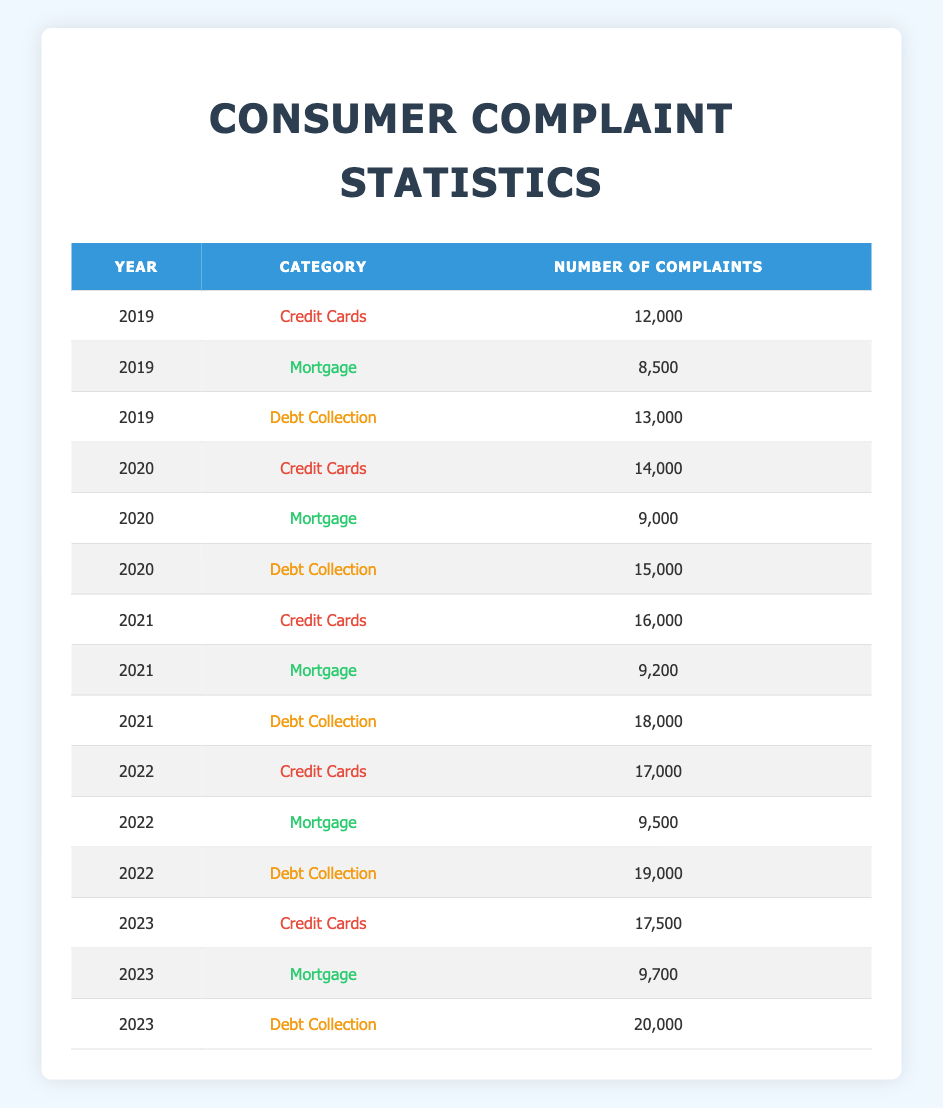What year had the highest number of complaints for mortgages? In the table, we look at the "Mortgage" category across each year. The counts are 8500 (2019), 9000 (2020), 9200 (2021), 9500 (2022), and 9700 (2023). The highest number is 9700 in 2023.
Answer: 2023 What is the total number of complaints for Debt Collection across all years? To find the total, we sum the complaints for Debt Collection: 13000 (2019) + 15000 (2020) + 18000 (2021) + 19000 (2022) + 20000 (2023) = 100000.
Answer: 100000 In 2021, how many more complaints were there for Credit Cards compared to Mortgages? The number of complaints for Credit Cards in 2021 is 16000, and for Mortgages, it is 9200. The difference is 16000 - 9200 = 6800.
Answer: 6800 Which category experienced the largest increase in complaints from 2019 to 2020? Looking at the increases: Credit Cards went from 12000 to 14000 (+2000), Mortgages from 8500 to 9000 (+500), and Debt Collection from 13000 to 15000 (+2000). The largest increase is tied with Credit Cards and Debt Collection, both at +2000.
Answer: Credit Cards and Debt Collection Was there an increase in the number of complaints for Credit Cards from 2022 to 2023? For Credit Cards, the complaints in 2022 are 17000 and in 2023 are 17500. 17500 > 17000 indicates an increase.
Answer: Yes What is the average number of complaints for Mortgages from 2019 to 2023? To calculate the average, we add the complaints for Mortgages: 8500 + 9000 + 9200 + 9500 + 9700 = 46900. There are 5 years, so the average is 46900 / 5 = 9380.
Answer: 9380 In which year did Debt Collection have the highest number of complaints, and what was that number? Analyzing the Debt Collection complaints, the values are 13000 (2019), 15000 (2020), 18000 (2021), 19000 (2022), and 20000 (2023). The highest is 20000 in 2023.
Answer: 2023 with 20000 complaints Is the number of complaints for Credit Cards consistently increasing each year? The counts for Credit Cards are: 12000 (2019), 14000 (2020), 16000 (2021), 17000 (2022), and 17500 (2023). Although there is an increase each year, the final increase from 2022 to 2023 is smaller than previous years (only +500). Thus, it is not an exponential increase.
Answer: No 